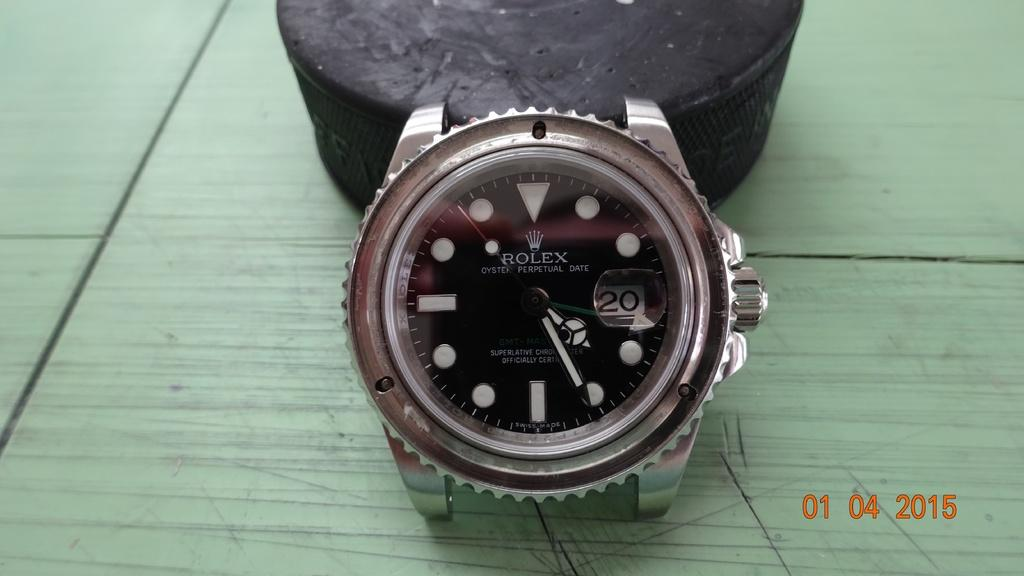Provide a one-sentence caption for the provided image. The silver metal watch on the table is a Rolex. 